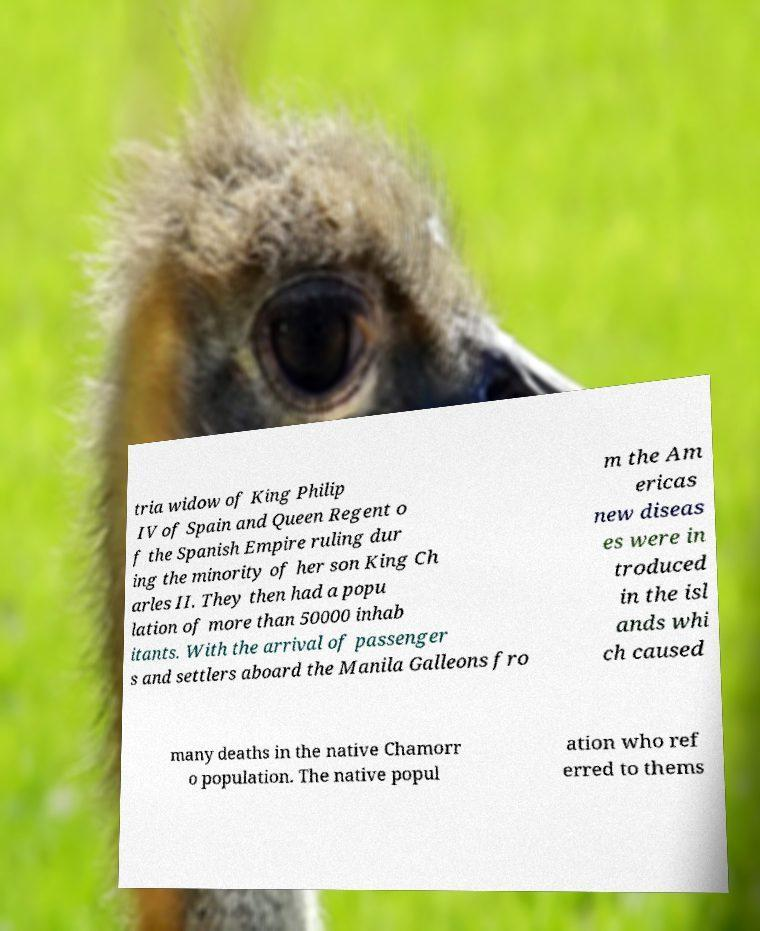Can you accurately transcribe the text from the provided image for me? tria widow of King Philip IV of Spain and Queen Regent o f the Spanish Empire ruling dur ing the minority of her son King Ch arles II. They then had a popu lation of more than 50000 inhab itants. With the arrival of passenger s and settlers aboard the Manila Galleons fro m the Am ericas new diseas es were in troduced in the isl ands whi ch caused many deaths in the native Chamorr o population. The native popul ation who ref erred to thems 